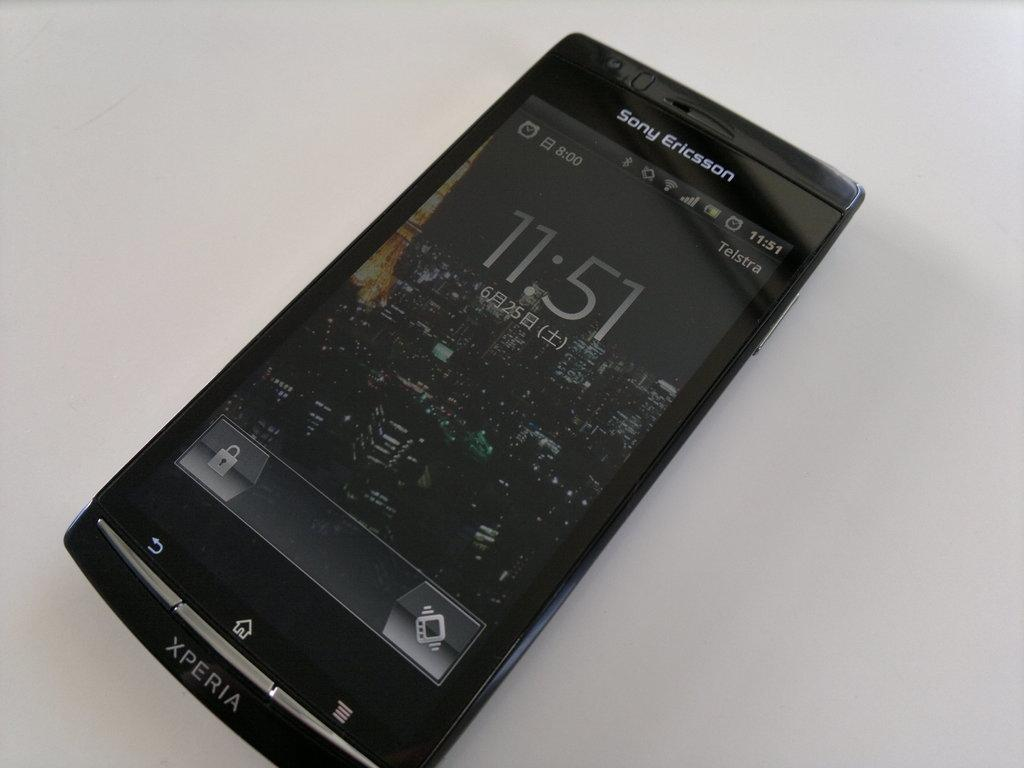<image>
Describe the image concisely. A home screen of a black Xperia Sony Ericsson phone. 